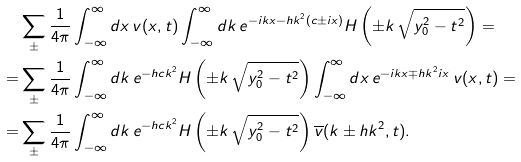Convert formula to latex. <formula><loc_0><loc_0><loc_500><loc_500>& \sum _ { \pm } \frac { 1 } { 4 \pi } \int _ { - \infty } ^ { \infty } d x \, v ( x , t ) \int _ { - \infty } ^ { \infty } d k \, e ^ { - i k x - h k ^ { 2 } ( c \pm i x ) } H \left ( \pm k \, \sqrt { y _ { 0 } ^ { 2 } - t ^ { 2 } } \right ) = \\ = & \sum _ { \pm } \frac { 1 } { 4 \pi } \int _ { - \infty } ^ { \infty } d k \, e ^ { - h c k ^ { 2 } } H \left ( \pm k \, \sqrt { y _ { 0 } ^ { 2 } - t ^ { 2 } } \right ) \int _ { - \infty } ^ { \infty } d x \, e ^ { - i k x \mp h k ^ { 2 } i x } \, v ( x , t ) = \\ = & \sum _ { \pm } \frac { 1 } { 4 \pi } \int _ { - \infty } ^ { \infty } d k \, e ^ { - h c k ^ { 2 } } H \left ( \pm k \, \sqrt { y _ { 0 } ^ { 2 } - t ^ { 2 } } \right ) \overline { v } ( k \pm h k ^ { 2 } , t ) .</formula> 